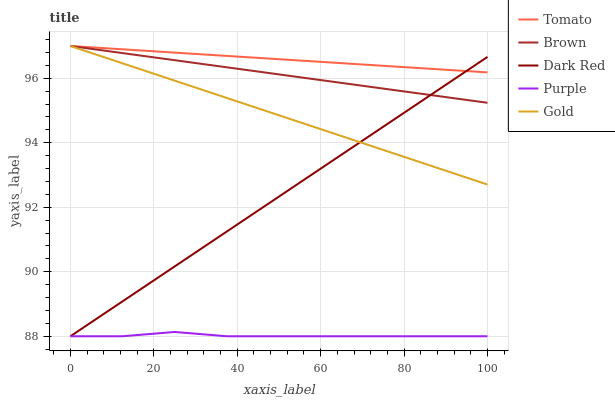Does Purple have the minimum area under the curve?
Answer yes or no. Yes. Does Tomato have the maximum area under the curve?
Answer yes or no. Yes. Does Brown have the minimum area under the curve?
Answer yes or no. No. Does Brown have the maximum area under the curve?
Answer yes or no. No. Is Tomato the smoothest?
Answer yes or no. Yes. Is Purple the roughest?
Answer yes or no. Yes. Is Brown the smoothest?
Answer yes or no. No. Is Brown the roughest?
Answer yes or no. No. Does Purple have the lowest value?
Answer yes or no. Yes. Does Brown have the lowest value?
Answer yes or no. No. Does Gold have the highest value?
Answer yes or no. Yes. Does Purple have the highest value?
Answer yes or no. No. Is Purple less than Tomato?
Answer yes or no. Yes. Is Brown greater than Purple?
Answer yes or no. Yes. Does Brown intersect Gold?
Answer yes or no. Yes. Is Brown less than Gold?
Answer yes or no. No. Is Brown greater than Gold?
Answer yes or no. No. Does Purple intersect Tomato?
Answer yes or no. No. 